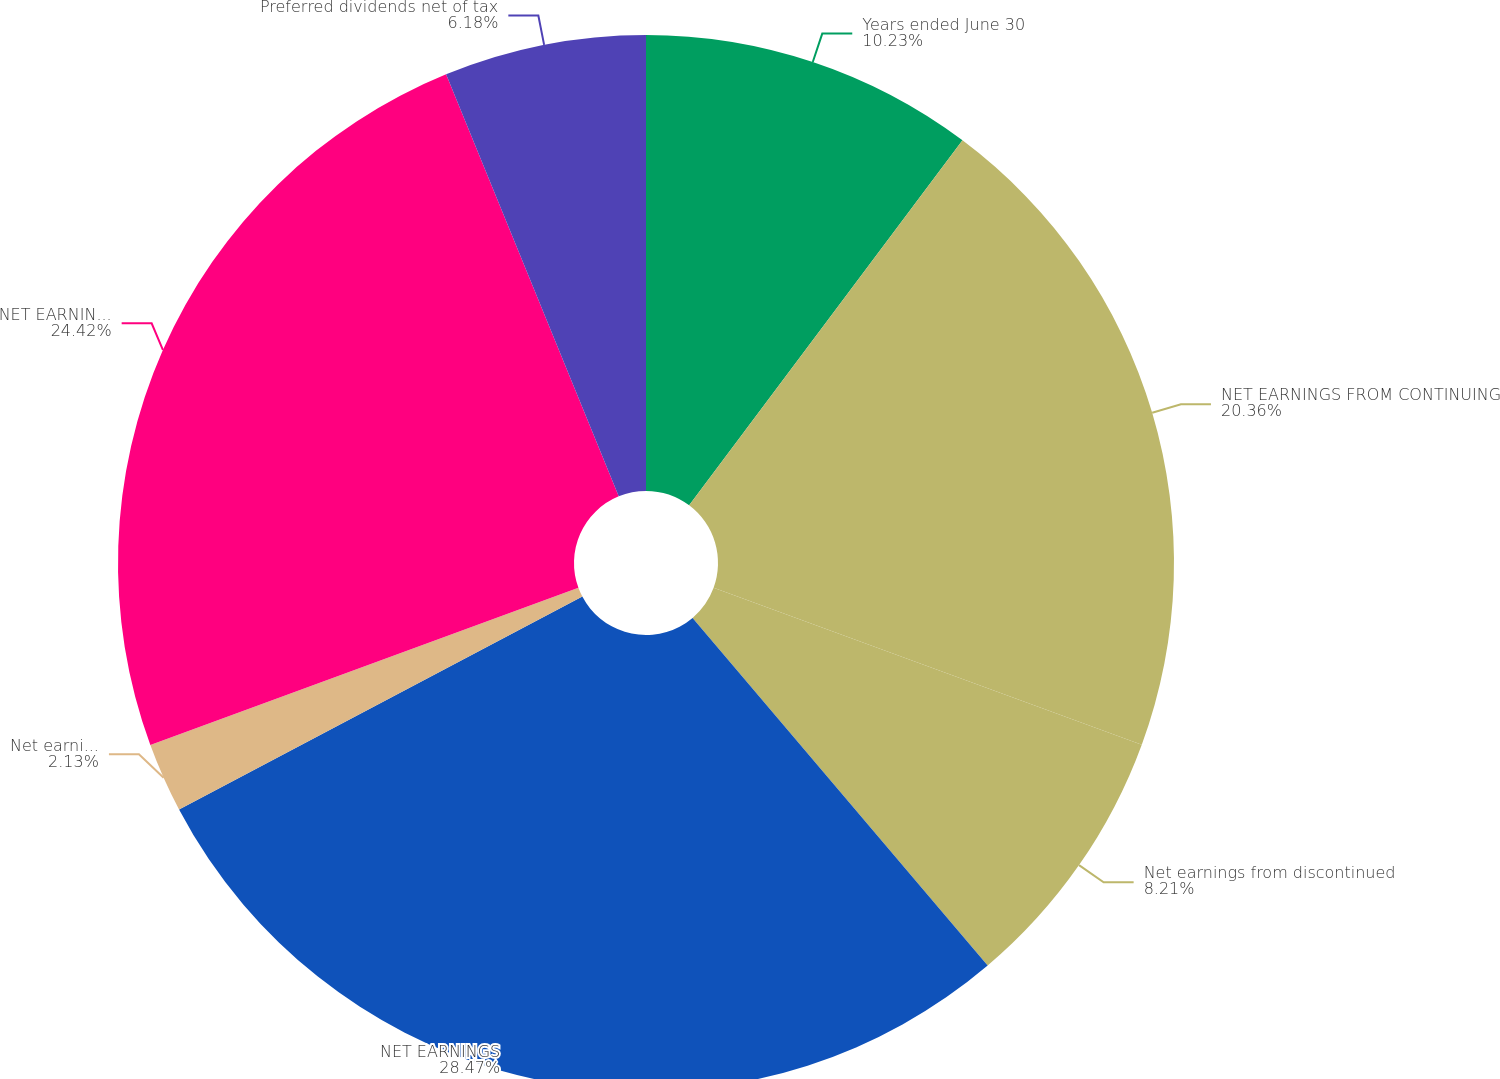Convert chart. <chart><loc_0><loc_0><loc_500><loc_500><pie_chart><fcel>Years ended June 30<fcel>NET EARNINGS FROM CONTINUING<fcel>Net earnings from discontinued<fcel>NET EARNINGS<fcel>Net earnings attributable to<fcel>NET EARNINGS ATTRIBUTABLE TO<fcel>Preferred dividends net of tax<nl><fcel>10.23%<fcel>20.36%<fcel>8.21%<fcel>28.47%<fcel>2.13%<fcel>24.42%<fcel>6.18%<nl></chart> 